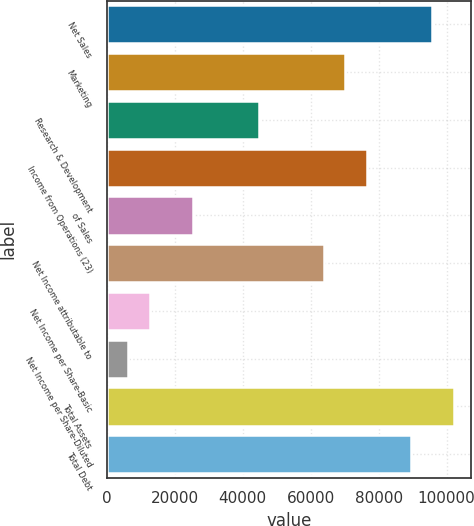Convert chart to OTSL. <chart><loc_0><loc_0><loc_500><loc_500><bar_chart><fcel>Net Sales<fcel>Marketing<fcel>Research & Development<fcel>Income from Operations (23)<fcel>of Sales<fcel>Net Income attributable to<fcel>Net Income per Share-Basic<fcel>Net Income per Share-Diluted<fcel>Total Assets<fcel>Total Debt<nl><fcel>95785.4<fcel>70242.7<fcel>44700<fcel>76628.4<fcel>25543<fcel>63857<fcel>12771.6<fcel>6385.92<fcel>102171<fcel>89399.8<nl></chart> 